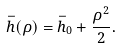Convert formula to latex. <formula><loc_0><loc_0><loc_500><loc_500>\bar { h } ( \rho ) = \bar { h } _ { 0 } + \frac { \rho ^ { 2 } } { 2 } .</formula> 